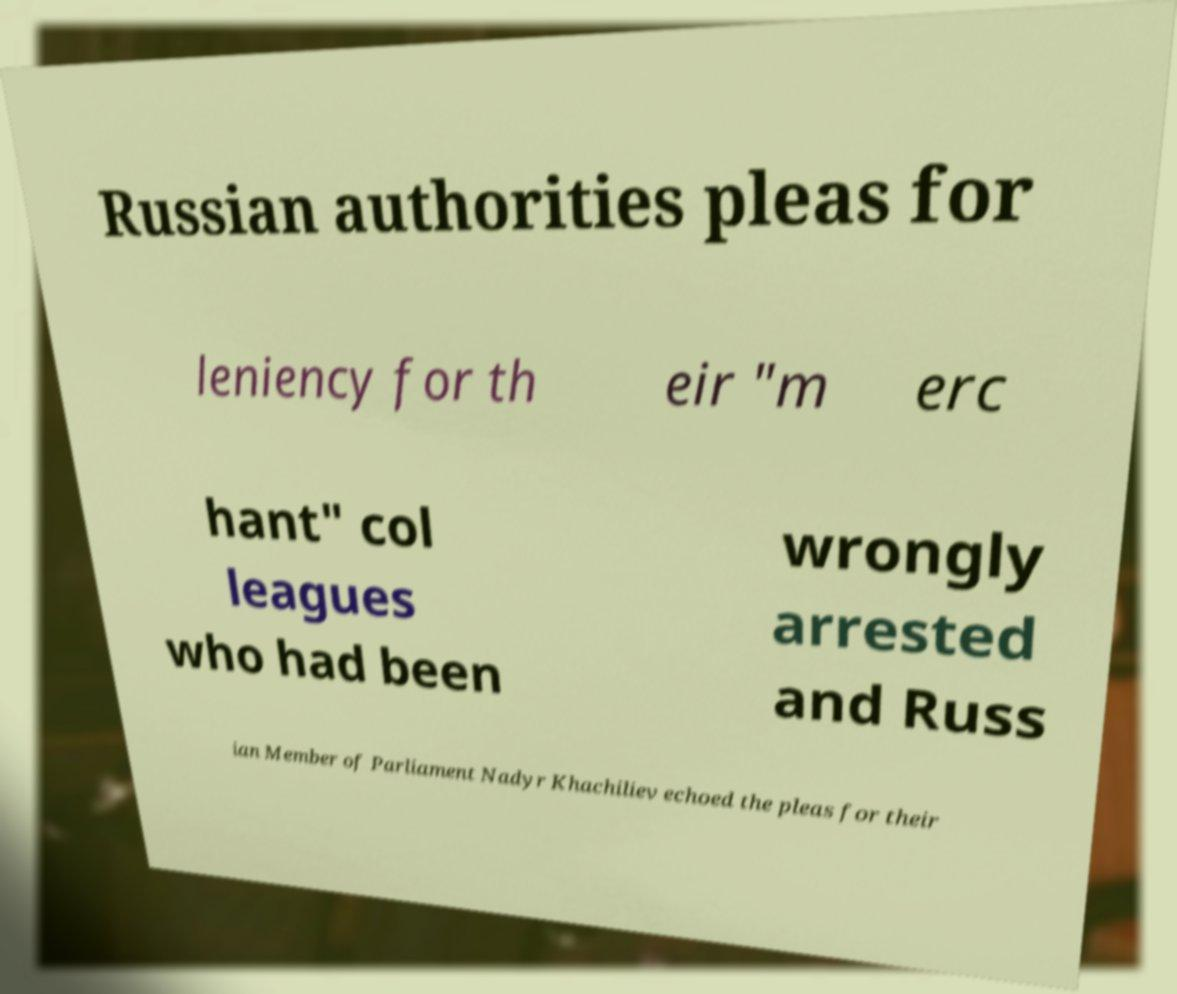There's text embedded in this image that I need extracted. Can you transcribe it verbatim? Russian authorities pleas for leniency for th eir "m erc hant" col leagues who had been wrongly arrested and Russ ian Member of Parliament Nadyr Khachiliev echoed the pleas for their 